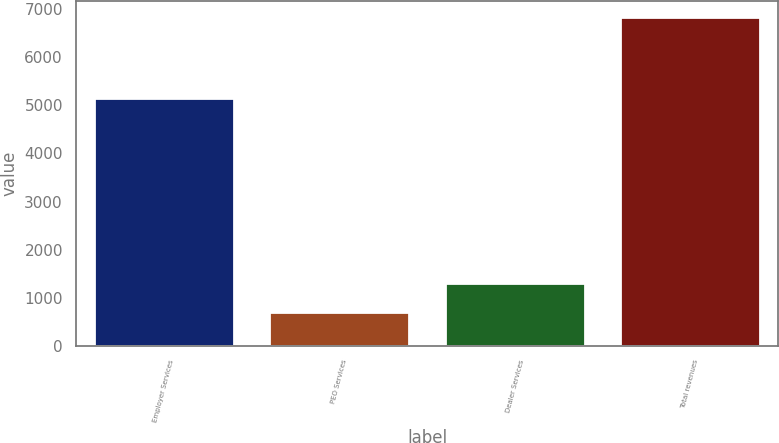Convert chart. <chart><loc_0><loc_0><loc_500><loc_500><bar_chart><fcel>Employer Services<fcel>PEO Services<fcel>Dealer Services<fcel>Total revenues<nl><fcel>5162.6<fcel>703.7<fcel>1316.89<fcel>6835.6<nl></chart> 